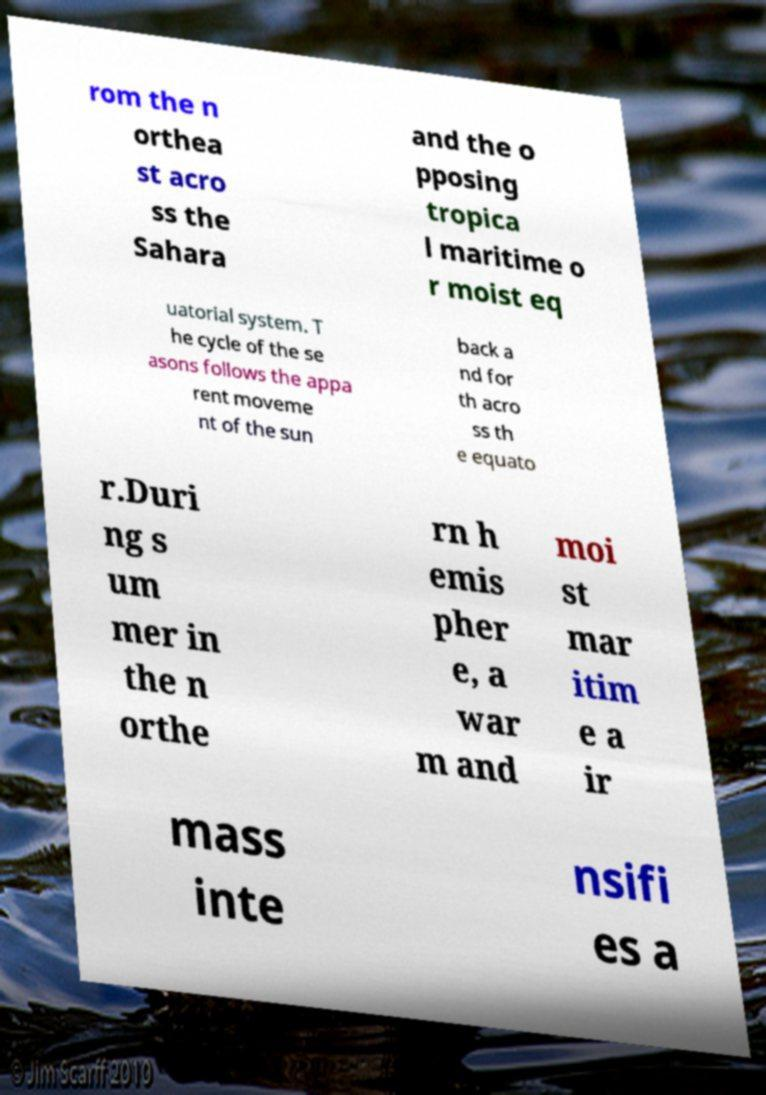There's text embedded in this image that I need extracted. Can you transcribe it verbatim? rom the n orthea st acro ss the Sahara and the o pposing tropica l maritime o r moist eq uatorial system. T he cycle of the se asons follows the appa rent moveme nt of the sun back a nd for th acro ss th e equato r.Duri ng s um mer in the n orthe rn h emis pher e, a war m and moi st mar itim e a ir mass inte nsifi es a 